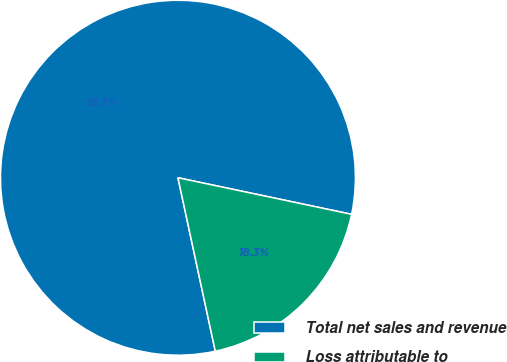Convert chart. <chart><loc_0><loc_0><loc_500><loc_500><pie_chart><fcel>Total net sales and revenue<fcel>Loss attributable to<nl><fcel>81.68%<fcel>18.32%<nl></chart> 